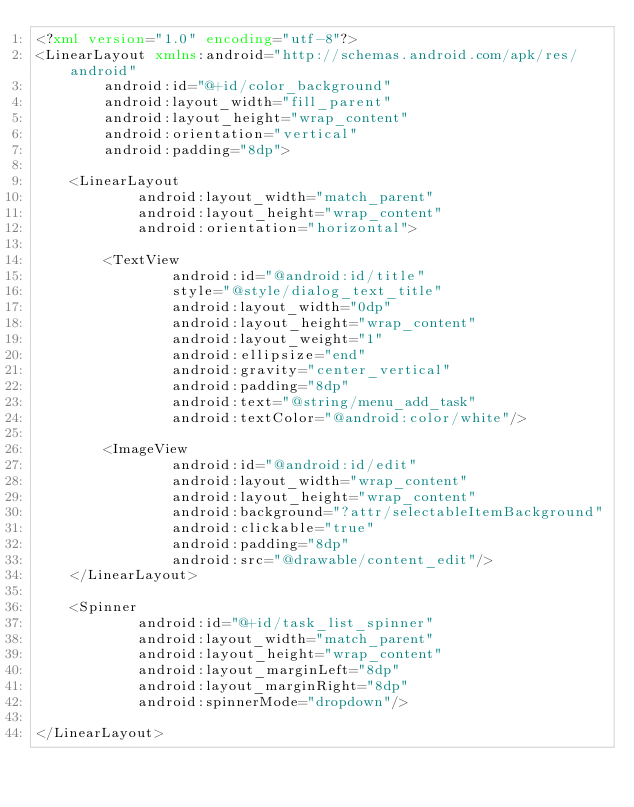<code> <loc_0><loc_0><loc_500><loc_500><_XML_><?xml version="1.0" encoding="utf-8"?>
<LinearLayout xmlns:android="http://schemas.android.com/apk/res/android"
        android:id="@+id/color_background"
        android:layout_width="fill_parent"
        android:layout_height="wrap_content"
        android:orientation="vertical"
        android:padding="8dp">

    <LinearLayout
            android:layout_width="match_parent"
            android:layout_height="wrap_content"
            android:orientation="horizontal">

        <TextView
                android:id="@android:id/title"
                style="@style/dialog_text_title"
                android:layout_width="0dp"
                android:layout_height="wrap_content"
                android:layout_weight="1"
                android:ellipsize="end"
                android:gravity="center_vertical"
                android:padding="8dp"
                android:text="@string/menu_add_task"
                android:textColor="@android:color/white"/>

        <ImageView
                android:id="@android:id/edit"
                android:layout_width="wrap_content"
                android:layout_height="wrap_content"
                android:background="?attr/selectableItemBackground"
                android:clickable="true"
                android:padding="8dp"
                android:src="@drawable/content_edit"/>
    </LinearLayout>

    <Spinner
            android:id="@+id/task_list_spinner"
            android:layout_width="match_parent"
            android:layout_height="wrap_content"
            android:layout_marginLeft="8dp"
            android:layout_marginRight="8dp"
            android:spinnerMode="dropdown"/>

</LinearLayout></code> 